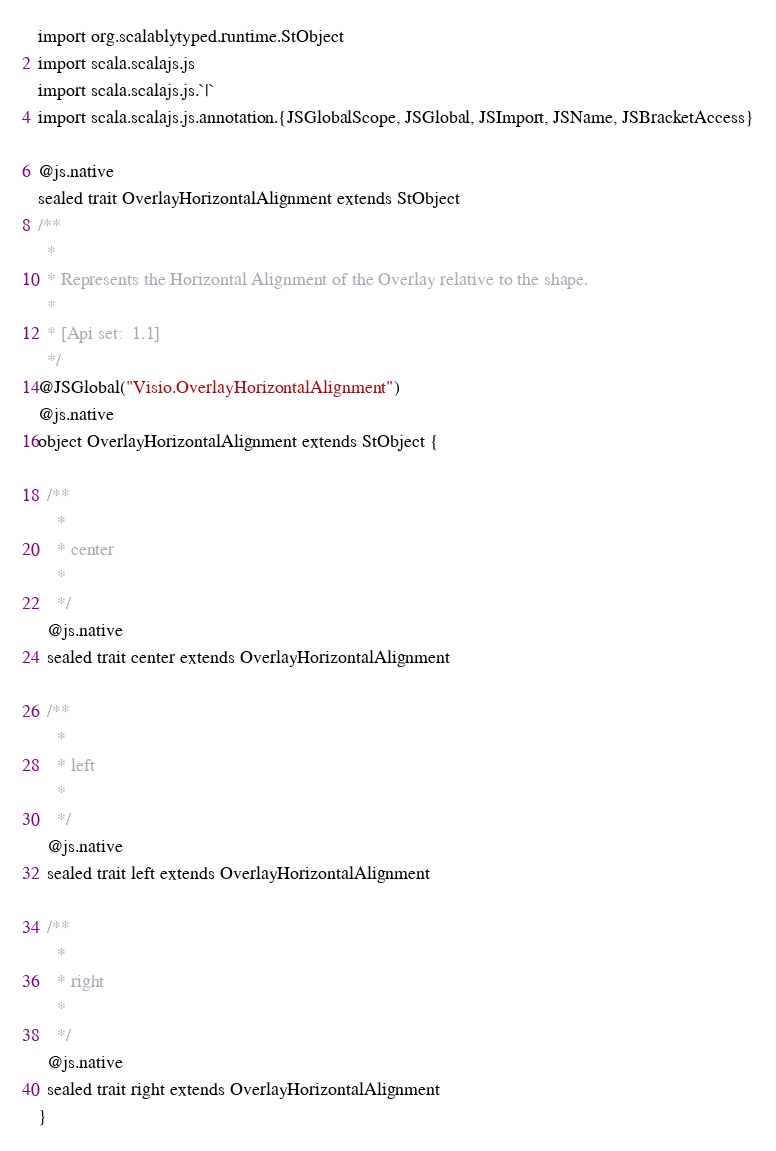<code> <loc_0><loc_0><loc_500><loc_500><_Scala_>
import org.scalablytyped.runtime.StObject
import scala.scalajs.js
import scala.scalajs.js.`|`
import scala.scalajs.js.annotation.{JSGlobalScope, JSGlobal, JSImport, JSName, JSBracketAccess}

@js.native
sealed trait OverlayHorizontalAlignment extends StObject
/**
  *
  * Represents the Horizontal Alignment of the Overlay relative to the shape.
  *
  * [Api set:  1.1]
  */
@JSGlobal("Visio.OverlayHorizontalAlignment")
@js.native
object OverlayHorizontalAlignment extends StObject {
  
  /**
    *
    * center
    *
    */
  @js.native
  sealed trait center extends OverlayHorizontalAlignment
  
  /**
    *
    * left
    *
    */
  @js.native
  sealed trait left extends OverlayHorizontalAlignment
  
  /**
    *
    * right
    *
    */
  @js.native
  sealed trait right extends OverlayHorizontalAlignment
}
</code> 